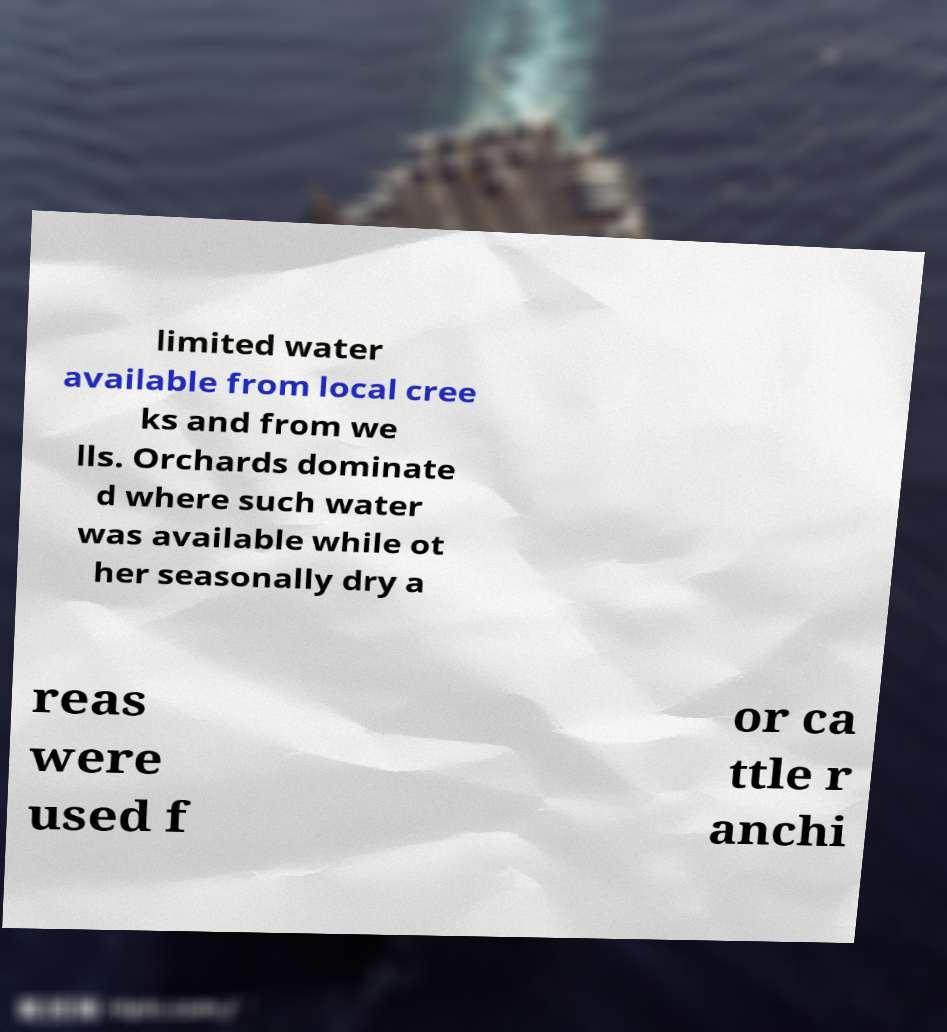Could you assist in decoding the text presented in this image and type it out clearly? limited water available from local cree ks and from we lls. Orchards dominate d where such water was available while ot her seasonally dry a reas were used f or ca ttle r anchi 